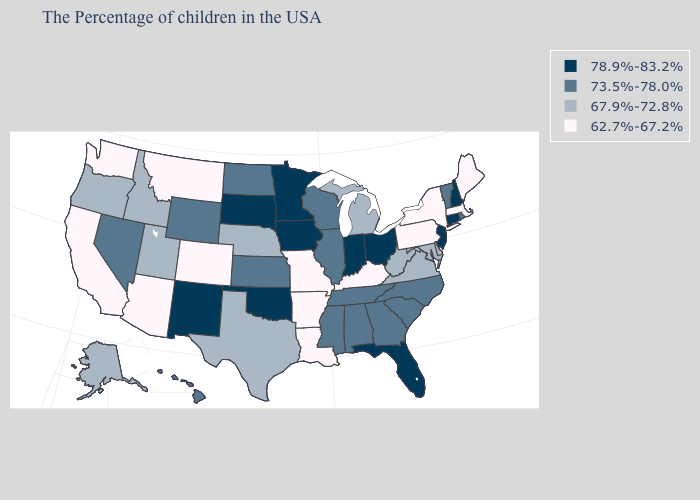Does the first symbol in the legend represent the smallest category?
Write a very short answer. No. What is the value of Indiana?
Quick response, please. 78.9%-83.2%. Among the states that border Connecticut , does Massachusetts have the highest value?
Give a very brief answer. No. Does Delaware have the same value as New Jersey?
Quick response, please. No. Name the states that have a value in the range 73.5%-78.0%?
Quick response, please. Rhode Island, Vermont, North Carolina, South Carolina, Georgia, Alabama, Tennessee, Wisconsin, Illinois, Mississippi, Kansas, North Dakota, Wyoming, Nevada, Hawaii. Does Texas have the highest value in the USA?
Be succinct. No. What is the value of Oklahoma?
Write a very short answer. 78.9%-83.2%. How many symbols are there in the legend?
Be succinct. 4. Which states have the lowest value in the MidWest?
Answer briefly. Missouri. What is the lowest value in states that border Nevada?
Keep it brief. 62.7%-67.2%. Does Colorado have the lowest value in the West?
Short answer required. Yes. Name the states that have a value in the range 62.7%-67.2%?
Concise answer only. Maine, Massachusetts, New York, Pennsylvania, Kentucky, Louisiana, Missouri, Arkansas, Colorado, Montana, Arizona, California, Washington. What is the value of California?
Concise answer only. 62.7%-67.2%. Which states have the lowest value in the South?
Keep it brief. Kentucky, Louisiana, Arkansas. 